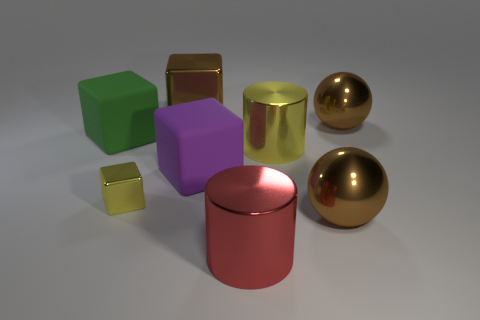Subtract all large cubes. How many cubes are left? 1 Add 1 small gray things. How many objects exist? 9 Subtract all yellow cubes. How many cubes are left? 3 Subtract all cylinders. How many objects are left? 6 Subtract all cyan blocks. Subtract all purple cylinders. How many blocks are left? 4 Add 2 large spheres. How many large spheres exist? 4 Subtract 1 green blocks. How many objects are left? 7 Subtract all big matte objects. Subtract all brown metal spheres. How many objects are left? 4 Add 5 cubes. How many cubes are left? 9 